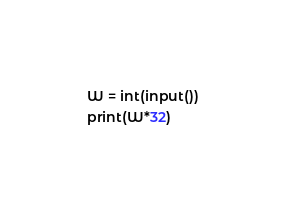<code> <loc_0><loc_0><loc_500><loc_500><_Python_>W = int(input())
print(W*32)
</code> 